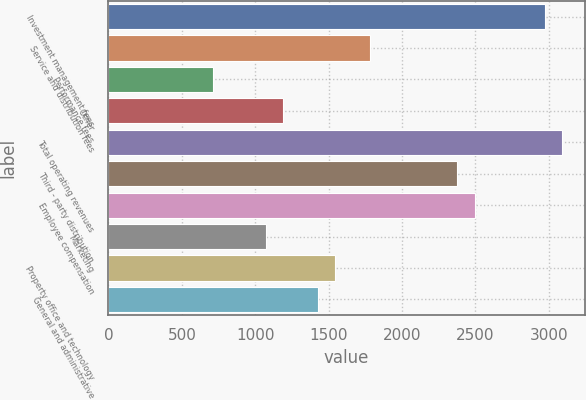Convert chart to OTSL. <chart><loc_0><loc_0><loc_500><loc_500><bar_chart><fcel>Investment management fees<fcel>Service and distribution fees<fcel>Performance fees<fcel>Other<fcel>Total operating revenues<fcel>Third - party distribution<fcel>Employee compensation<fcel>Marketing<fcel>Property office and technology<fcel>General and administrative<nl><fcel>2973.03<fcel>1783.93<fcel>713.74<fcel>1189.38<fcel>3091.94<fcel>2378.48<fcel>2497.39<fcel>1070.47<fcel>1546.11<fcel>1427.2<nl></chart> 